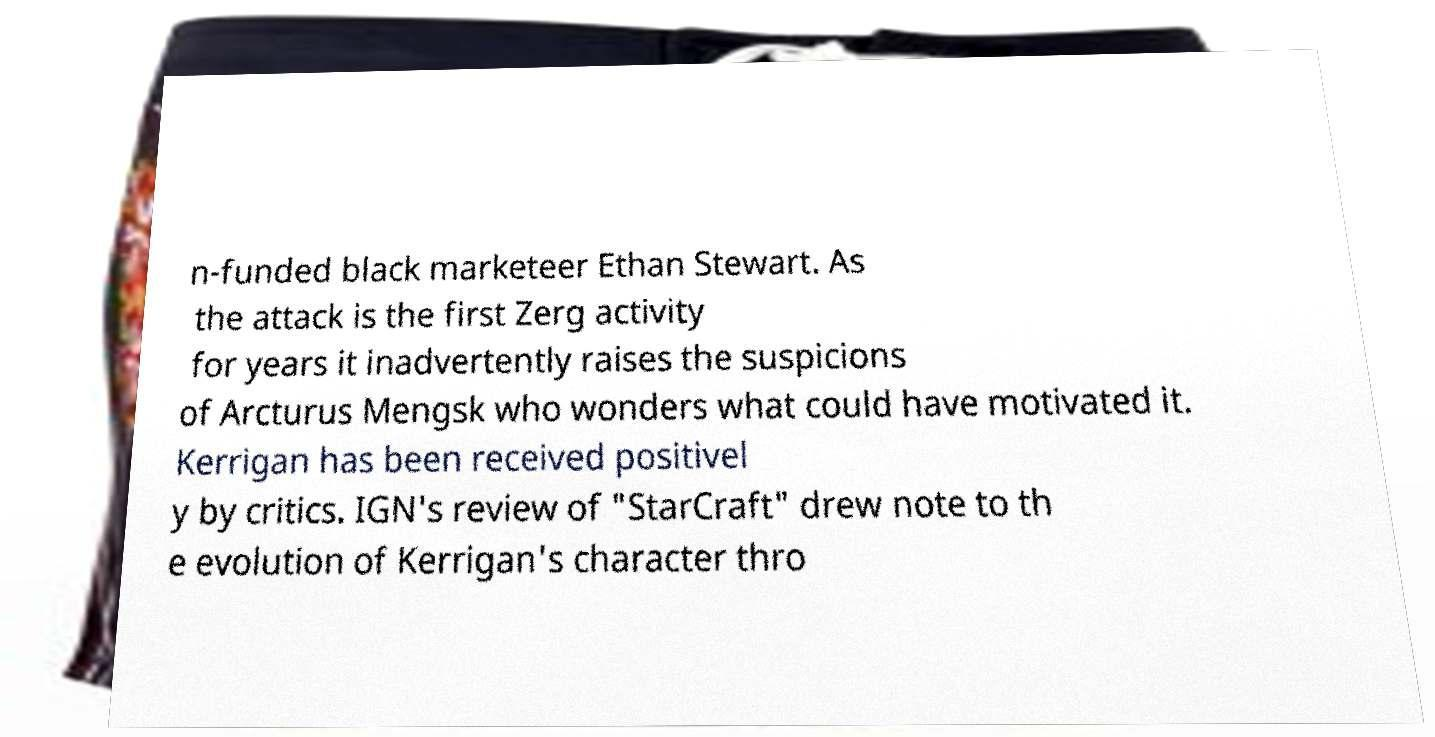I need the written content from this picture converted into text. Can you do that? n-funded black marketeer Ethan Stewart. As the attack is the first Zerg activity for years it inadvertently raises the suspicions of Arcturus Mengsk who wonders what could have motivated it. Kerrigan has been received positivel y by critics. IGN's review of "StarCraft" drew note to th e evolution of Kerrigan's character thro 